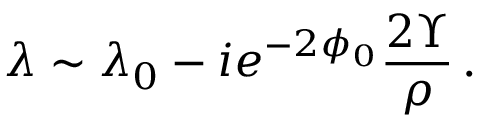Convert formula to latex. <formula><loc_0><loc_0><loc_500><loc_500>\lambda \sim \lambda _ { 0 } - i e ^ { - 2 \phi _ { 0 } } \frac { 2 \Upsilon } { \rho } \, .</formula> 